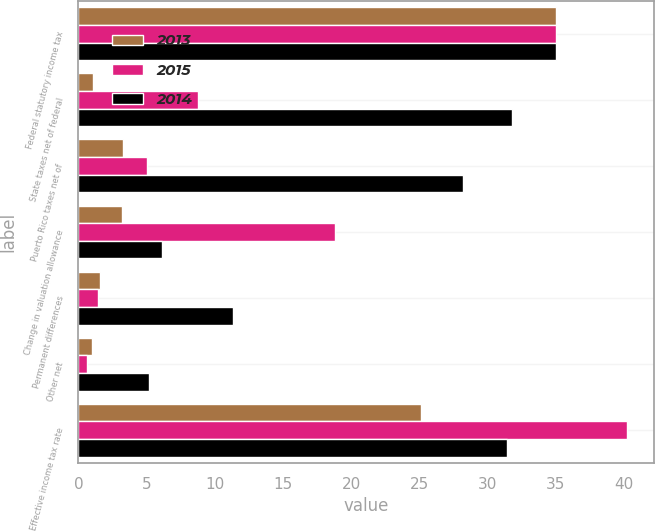Convert chart. <chart><loc_0><loc_0><loc_500><loc_500><stacked_bar_chart><ecel><fcel>Federal statutory income tax<fcel>State taxes net of federal<fcel>Puerto Rico taxes net of<fcel>Change in valuation allowance<fcel>Permanent differences<fcel>Other net<fcel>Effective income tax rate<nl><fcel>2013<fcel>35<fcel>1.1<fcel>3.3<fcel>3.2<fcel>1.6<fcel>1<fcel>25.1<nl><fcel>2015<fcel>35<fcel>8.8<fcel>5<fcel>18.8<fcel>1.4<fcel>0.6<fcel>40.2<nl><fcel>2014<fcel>35<fcel>31.8<fcel>28.2<fcel>6.1<fcel>11.3<fcel>5.2<fcel>31.4<nl></chart> 